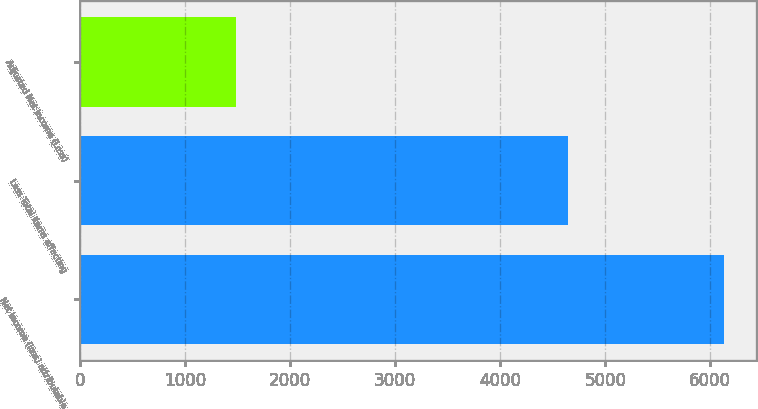Convert chart. <chart><loc_0><loc_0><loc_500><loc_500><bar_chart><fcel>Net income (loss) attributable<fcel>Less Total items affecting<fcel>Adjusted Net Income (Loss)<nl><fcel>6132<fcel>4643<fcel>1489<nl></chart> 